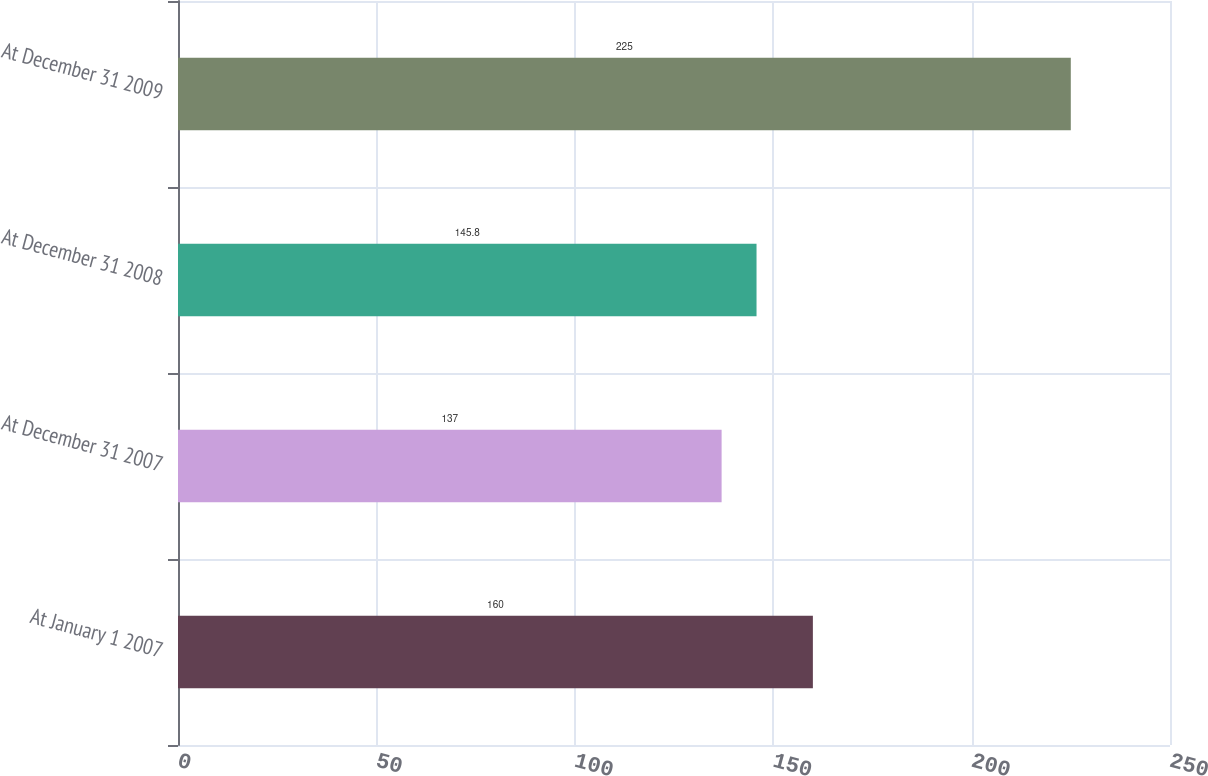Convert chart to OTSL. <chart><loc_0><loc_0><loc_500><loc_500><bar_chart><fcel>At January 1 2007<fcel>At December 31 2007<fcel>At December 31 2008<fcel>At December 31 2009<nl><fcel>160<fcel>137<fcel>145.8<fcel>225<nl></chart> 